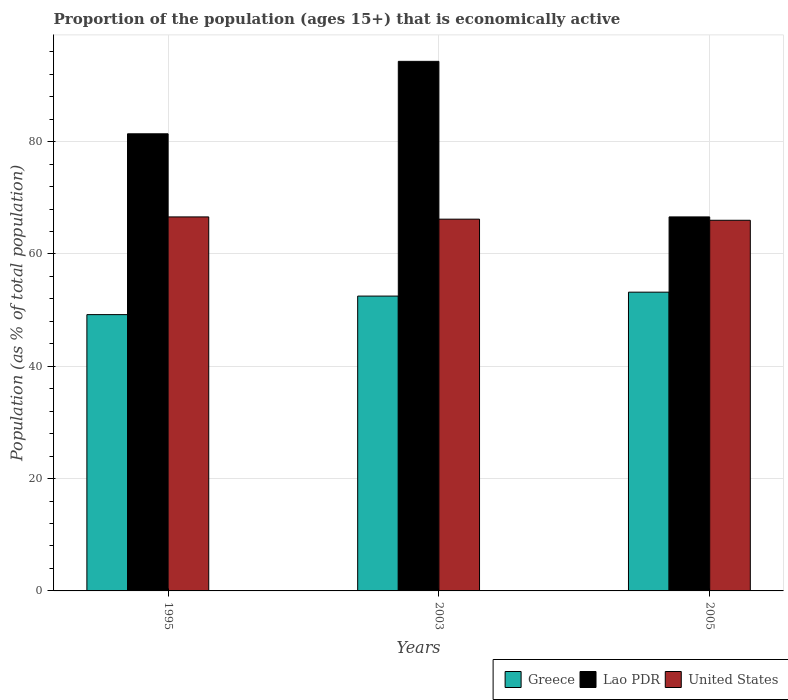Are the number of bars on each tick of the X-axis equal?
Keep it short and to the point. Yes. How many bars are there on the 2nd tick from the left?
Your answer should be compact. 3. In how many cases, is the number of bars for a given year not equal to the number of legend labels?
Your answer should be very brief. 0. What is the proportion of the population that is economically active in Greece in 2003?
Provide a short and direct response. 52.5. Across all years, what is the maximum proportion of the population that is economically active in Lao PDR?
Provide a short and direct response. 94.3. Across all years, what is the minimum proportion of the population that is economically active in Lao PDR?
Your answer should be very brief. 66.6. In which year was the proportion of the population that is economically active in Greece maximum?
Provide a succinct answer. 2005. What is the total proportion of the population that is economically active in United States in the graph?
Offer a terse response. 198.8. What is the difference between the proportion of the population that is economically active in Greece in 1995 and that in 2003?
Ensure brevity in your answer.  -3.3. What is the difference between the proportion of the population that is economically active in Lao PDR in 2003 and the proportion of the population that is economically active in Greece in 1995?
Make the answer very short. 45.1. What is the average proportion of the population that is economically active in Lao PDR per year?
Your answer should be compact. 80.77. In the year 2003, what is the difference between the proportion of the population that is economically active in Lao PDR and proportion of the population that is economically active in United States?
Keep it short and to the point. 28.1. In how many years, is the proportion of the population that is economically active in Lao PDR greater than 36 %?
Your response must be concise. 3. What is the ratio of the proportion of the population that is economically active in Lao PDR in 1995 to that in 2005?
Offer a terse response. 1.22. Is the proportion of the population that is economically active in Greece in 1995 less than that in 2005?
Offer a terse response. Yes. What is the difference between the highest and the second highest proportion of the population that is economically active in Lao PDR?
Your answer should be very brief. 12.9. What is the difference between the highest and the lowest proportion of the population that is economically active in Lao PDR?
Ensure brevity in your answer.  27.7. What does the 2nd bar from the left in 2005 represents?
Your answer should be very brief. Lao PDR. What does the 2nd bar from the right in 1995 represents?
Give a very brief answer. Lao PDR. How many bars are there?
Keep it short and to the point. 9. Are all the bars in the graph horizontal?
Provide a succinct answer. No. How many years are there in the graph?
Your answer should be very brief. 3. What is the difference between two consecutive major ticks on the Y-axis?
Provide a succinct answer. 20. Does the graph contain any zero values?
Your answer should be compact. No. Does the graph contain grids?
Provide a succinct answer. Yes. Where does the legend appear in the graph?
Offer a terse response. Bottom right. What is the title of the graph?
Provide a succinct answer. Proportion of the population (ages 15+) that is economically active. Does "Latvia" appear as one of the legend labels in the graph?
Give a very brief answer. No. What is the label or title of the Y-axis?
Offer a terse response. Population (as % of total population). What is the Population (as % of total population) in Greece in 1995?
Offer a very short reply. 49.2. What is the Population (as % of total population) of Lao PDR in 1995?
Ensure brevity in your answer.  81.4. What is the Population (as % of total population) of United States in 1995?
Ensure brevity in your answer.  66.6. What is the Population (as % of total population) in Greece in 2003?
Keep it short and to the point. 52.5. What is the Population (as % of total population) of Lao PDR in 2003?
Ensure brevity in your answer.  94.3. What is the Population (as % of total population) in United States in 2003?
Offer a very short reply. 66.2. What is the Population (as % of total population) in Greece in 2005?
Provide a short and direct response. 53.2. What is the Population (as % of total population) of Lao PDR in 2005?
Give a very brief answer. 66.6. Across all years, what is the maximum Population (as % of total population) in Greece?
Your response must be concise. 53.2. Across all years, what is the maximum Population (as % of total population) of Lao PDR?
Provide a short and direct response. 94.3. Across all years, what is the maximum Population (as % of total population) in United States?
Make the answer very short. 66.6. Across all years, what is the minimum Population (as % of total population) in Greece?
Offer a terse response. 49.2. Across all years, what is the minimum Population (as % of total population) in Lao PDR?
Offer a terse response. 66.6. What is the total Population (as % of total population) in Greece in the graph?
Offer a terse response. 154.9. What is the total Population (as % of total population) in Lao PDR in the graph?
Your response must be concise. 242.3. What is the total Population (as % of total population) of United States in the graph?
Provide a short and direct response. 198.8. What is the difference between the Population (as % of total population) in Lao PDR in 1995 and that in 2003?
Your answer should be very brief. -12.9. What is the difference between the Population (as % of total population) in United States in 1995 and that in 2003?
Your response must be concise. 0.4. What is the difference between the Population (as % of total population) of Greece in 1995 and that in 2005?
Provide a short and direct response. -4. What is the difference between the Population (as % of total population) in Greece in 2003 and that in 2005?
Provide a short and direct response. -0.7. What is the difference between the Population (as % of total population) in Lao PDR in 2003 and that in 2005?
Provide a short and direct response. 27.7. What is the difference between the Population (as % of total population) of United States in 2003 and that in 2005?
Keep it short and to the point. 0.2. What is the difference between the Population (as % of total population) of Greece in 1995 and the Population (as % of total population) of Lao PDR in 2003?
Your response must be concise. -45.1. What is the difference between the Population (as % of total population) of Greece in 1995 and the Population (as % of total population) of United States in 2003?
Offer a very short reply. -17. What is the difference between the Population (as % of total population) of Greece in 1995 and the Population (as % of total population) of Lao PDR in 2005?
Offer a terse response. -17.4. What is the difference between the Population (as % of total population) in Greece in 1995 and the Population (as % of total population) in United States in 2005?
Your answer should be very brief. -16.8. What is the difference between the Population (as % of total population) of Greece in 2003 and the Population (as % of total population) of Lao PDR in 2005?
Make the answer very short. -14.1. What is the difference between the Population (as % of total population) of Lao PDR in 2003 and the Population (as % of total population) of United States in 2005?
Make the answer very short. 28.3. What is the average Population (as % of total population) in Greece per year?
Offer a very short reply. 51.63. What is the average Population (as % of total population) in Lao PDR per year?
Make the answer very short. 80.77. What is the average Population (as % of total population) in United States per year?
Your answer should be compact. 66.27. In the year 1995, what is the difference between the Population (as % of total population) in Greece and Population (as % of total population) in Lao PDR?
Make the answer very short. -32.2. In the year 1995, what is the difference between the Population (as % of total population) of Greece and Population (as % of total population) of United States?
Ensure brevity in your answer.  -17.4. In the year 1995, what is the difference between the Population (as % of total population) of Lao PDR and Population (as % of total population) of United States?
Your response must be concise. 14.8. In the year 2003, what is the difference between the Population (as % of total population) of Greece and Population (as % of total population) of Lao PDR?
Provide a succinct answer. -41.8. In the year 2003, what is the difference between the Population (as % of total population) of Greece and Population (as % of total population) of United States?
Offer a terse response. -13.7. In the year 2003, what is the difference between the Population (as % of total population) in Lao PDR and Population (as % of total population) in United States?
Make the answer very short. 28.1. What is the ratio of the Population (as % of total population) in Greece in 1995 to that in 2003?
Make the answer very short. 0.94. What is the ratio of the Population (as % of total population) of Lao PDR in 1995 to that in 2003?
Provide a succinct answer. 0.86. What is the ratio of the Population (as % of total population) of United States in 1995 to that in 2003?
Keep it short and to the point. 1.01. What is the ratio of the Population (as % of total population) in Greece in 1995 to that in 2005?
Offer a very short reply. 0.92. What is the ratio of the Population (as % of total population) of Lao PDR in 1995 to that in 2005?
Provide a short and direct response. 1.22. What is the ratio of the Population (as % of total population) of United States in 1995 to that in 2005?
Ensure brevity in your answer.  1.01. What is the ratio of the Population (as % of total population) in Lao PDR in 2003 to that in 2005?
Your response must be concise. 1.42. What is the ratio of the Population (as % of total population) in United States in 2003 to that in 2005?
Provide a succinct answer. 1. What is the difference between the highest and the second highest Population (as % of total population) of Lao PDR?
Keep it short and to the point. 12.9. What is the difference between the highest and the second highest Population (as % of total population) in United States?
Offer a terse response. 0.4. What is the difference between the highest and the lowest Population (as % of total population) of Greece?
Give a very brief answer. 4. What is the difference between the highest and the lowest Population (as % of total population) in Lao PDR?
Keep it short and to the point. 27.7. 